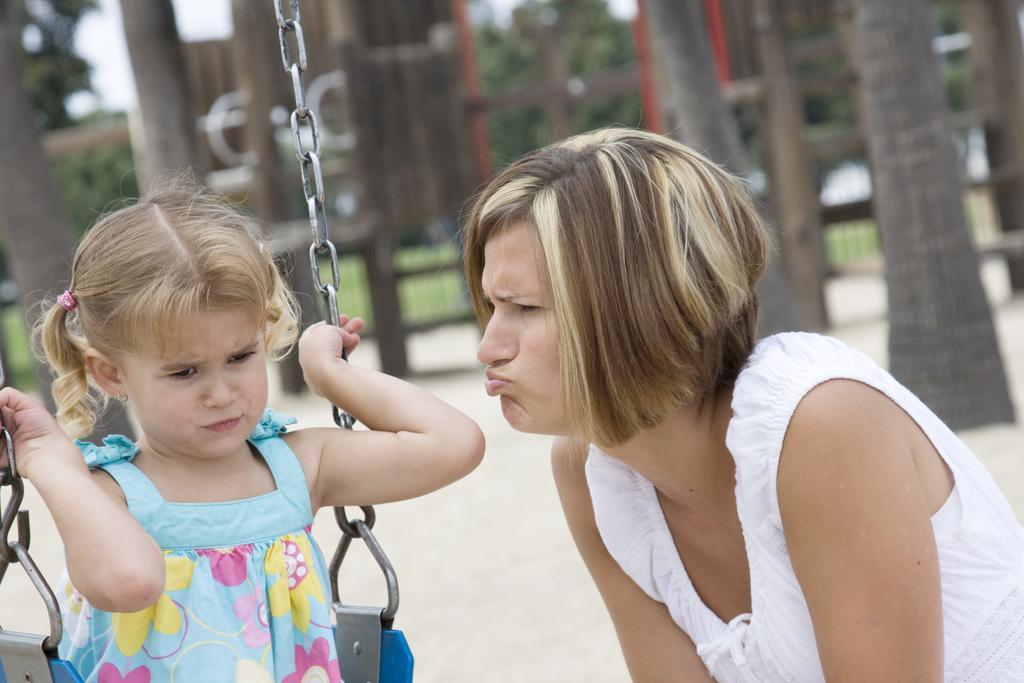Please provide a concise description of this image. In this picture we can see a person is standing on the path and a kid is sitting on the swing. Behind the people there are trees, tree trunks and some blurred objects. 